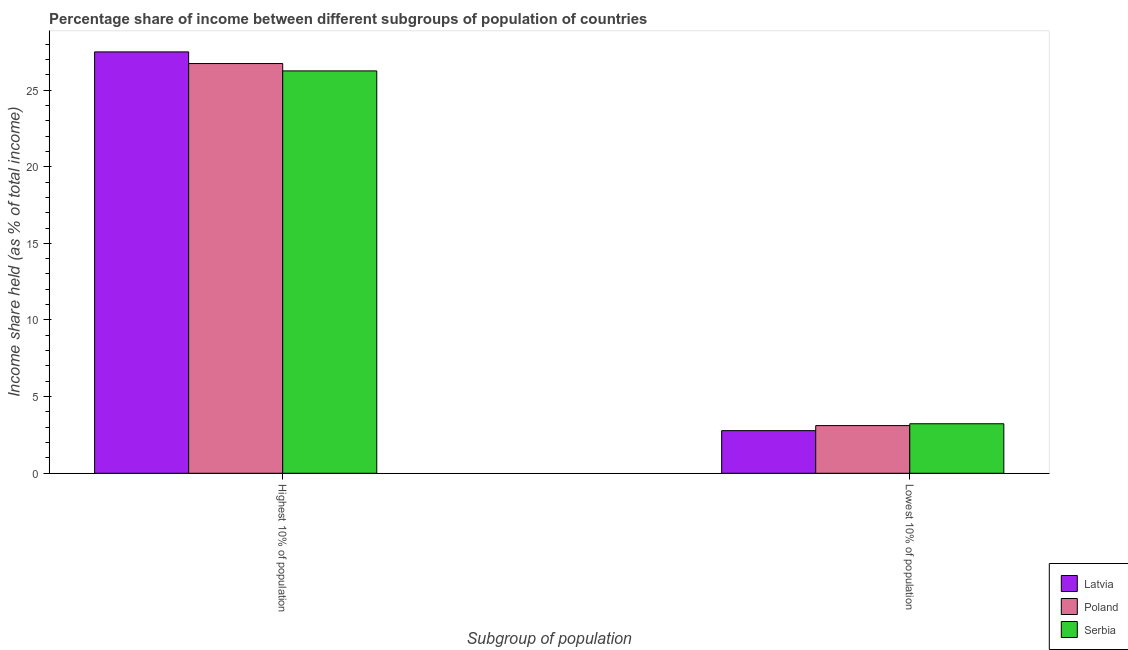How many different coloured bars are there?
Offer a very short reply. 3. How many groups of bars are there?
Ensure brevity in your answer.  2. Are the number of bars on each tick of the X-axis equal?
Make the answer very short. Yes. How many bars are there on the 1st tick from the left?
Give a very brief answer. 3. How many bars are there on the 1st tick from the right?
Your answer should be very brief. 3. What is the label of the 1st group of bars from the left?
Offer a very short reply. Highest 10% of population. What is the income share held by highest 10% of the population in Serbia?
Give a very brief answer. 26.25. Across all countries, what is the maximum income share held by lowest 10% of the population?
Offer a very short reply. 3.23. Across all countries, what is the minimum income share held by highest 10% of the population?
Give a very brief answer. 26.25. In which country was the income share held by lowest 10% of the population maximum?
Your response must be concise. Serbia. In which country was the income share held by highest 10% of the population minimum?
Give a very brief answer. Serbia. What is the total income share held by highest 10% of the population in the graph?
Give a very brief answer. 80.47. What is the difference between the income share held by highest 10% of the population in Poland and that in Serbia?
Offer a very short reply. 0.48. What is the difference between the income share held by lowest 10% of the population in Serbia and the income share held by highest 10% of the population in Poland?
Keep it short and to the point. -23.5. What is the average income share held by highest 10% of the population per country?
Keep it short and to the point. 26.82. What is the difference between the income share held by lowest 10% of the population and income share held by highest 10% of the population in Poland?
Your answer should be compact. -23.62. In how many countries, is the income share held by lowest 10% of the population greater than 2 %?
Offer a terse response. 3. What is the ratio of the income share held by lowest 10% of the population in Poland to that in Latvia?
Your response must be concise. 1.12. In how many countries, is the income share held by lowest 10% of the population greater than the average income share held by lowest 10% of the population taken over all countries?
Your answer should be compact. 2. What does the 1st bar from the left in Highest 10% of population represents?
Provide a succinct answer. Latvia. What does the 1st bar from the right in Lowest 10% of population represents?
Ensure brevity in your answer.  Serbia. How many bars are there?
Provide a succinct answer. 6. Are all the bars in the graph horizontal?
Keep it short and to the point. No. How many countries are there in the graph?
Give a very brief answer. 3. What is the difference between two consecutive major ticks on the Y-axis?
Give a very brief answer. 5. Are the values on the major ticks of Y-axis written in scientific E-notation?
Provide a succinct answer. No. Does the graph contain any zero values?
Give a very brief answer. No. Does the graph contain grids?
Your answer should be compact. No. Where does the legend appear in the graph?
Offer a terse response. Bottom right. What is the title of the graph?
Your response must be concise. Percentage share of income between different subgroups of population of countries. Does "Lao PDR" appear as one of the legend labels in the graph?
Keep it short and to the point. No. What is the label or title of the X-axis?
Keep it short and to the point. Subgroup of population. What is the label or title of the Y-axis?
Keep it short and to the point. Income share held (as % of total income). What is the Income share held (as % of total income) of Latvia in Highest 10% of population?
Your answer should be compact. 27.49. What is the Income share held (as % of total income) of Poland in Highest 10% of population?
Your answer should be very brief. 26.73. What is the Income share held (as % of total income) of Serbia in Highest 10% of population?
Make the answer very short. 26.25. What is the Income share held (as % of total income) of Latvia in Lowest 10% of population?
Provide a succinct answer. 2.78. What is the Income share held (as % of total income) of Poland in Lowest 10% of population?
Keep it short and to the point. 3.11. What is the Income share held (as % of total income) of Serbia in Lowest 10% of population?
Give a very brief answer. 3.23. Across all Subgroup of population, what is the maximum Income share held (as % of total income) of Latvia?
Give a very brief answer. 27.49. Across all Subgroup of population, what is the maximum Income share held (as % of total income) in Poland?
Make the answer very short. 26.73. Across all Subgroup of population, what is the maximum Income share held (as % of total income) of Serbia?
Your answer should be very brief. 26.25. Across all Subgroup of population, what is the minimum Income share held (as % of total income) of Latvia?
Offer a terse response. 2.78. Across all Subgroup of population, what is the minimum Income share held (as % of total income) of Poland?
Your answer should be very brief. 3.11. Across all Subgroup of population, what is the minimum Income share held (as % of total income) in Serbia?
Make the answer very short. 3.23. What is the total Income share held (as % of total income) of Latvia in the graph?
Give a very brief answer. 30.27. What is the total Income share held (as % of total income) of Poland in the graph?
Ensure brevity in your answer.  29.84. What is the total Income share held (as % of total income) in Serbia in the graph?
Provide a succinct answer. 29.48. What is the difference between the Income share held (as % of total income) in Latvia in Highest 10% of population and that in Lowest 10% of population?
Your response must be concise. 24.71. What is the difference between the Income share held (as % of total income) of Poland in Highest 10% of population and that in Lowest 10% of population?
Offer a very short reply. 23.62. What is the difference between the Income share held (as % of total income) of Serbia in Highest 10% of population and that in Lowest 10% of population?
Give a very brief answer. 23.02. What is the difference between the Income share held (as % of total income) of Latvia in Highest 10% of population and the Income share held (as % of total income) of Poland in Lowest 10% of population?
Offer a very short reply. 24.38. What is the difference between the Income share held (as % of total income) in Latvia in Highest 10% of population and the Income share held (as % of total income) in Serbia in Lowest 10% of population?
Your response must be concise. 24.26. What is the difference between the Income share held (as % of total income) in Poland in Highest 10% of population and the Income share held (as % of total income) in Serbia in Lowest 10% of population?
Your answer should be compact. 23.5. What is the average Income share held (as % of total income) of Latvia per Subgroup of population?
Your answer should be compact. 15.13. What is the average Income share held (as % of total income) in Poland per Subgroup of population?
Ensure brevity in your answer.  14.92. What is the average Income share held (as % of total income) in Serbia per Subgroup of population?
Provide a short and direct response. 14.74. What is the difference between the Income share held (as % of total income) in Latvia and Income share held (as % of total income) in Poland in Highest 10% of population?
Keep it short and to the point. 0.76. What is the difference between the Income share held (as % of total income) of Latvia and Income share held (as % of total income) of Serbia in Highest 10% of population?
Give a very brief answer. 1.24. What is the difference between the Income share held (as % of total income) of Poland and Income share held (as % of total income) of Serbia in Highest 10% of population?
Offer a very short reply. 0.48. What is the difference between the Income share held (as % of total income) in Latvia and Income share held (as % of total income) in Poland in Lowest 10% of population?
Your response must be concise. -0.33. What is the difference between the Income share held (as % of total income) of Latvia and Income share held (as % of total income) of Serbia in Lowest 10% of population?
Give a very brief answer. -0.45. What is the difference between the Income share held (as % of total income) of Poland and Income share held (as % of total income) of Serbia in Lowest 10% of population?
Offer a very short reply. -0.12. What is the ratio of the Income share held (as % of total income) in Latvia in Highest 10% of population to that in Lowest 10% of population?
Keep it short and to the point. 9.89. What is the ratio of the Income share held (as % of total income) of Poland in Highest 10% of population to that in Lowest 10% of population?
Keep it short and to the point. 8.59. What is the ratio of the Income share held (as % of total income) in Serbia in Highest 10% of population to that in Lowest 10% of population?
Keep it short and to the point. 8.13. What is the difference between the highest and the second highest Income share held (as % of total income) in Latvia?
Provide a short and direct response. 24.71. What is the difference between the highest and the second highest Income share held (as % of total income) of Poland?
Make the answer very short. 23.62. What is the difference between the highest and the second highest Income share held (as % of total income) in Serbia?
Give a very brief answer. 23.02. What is the difference between the highest and the lowest Income share held (as % of total income) of Latvia?
Ensure brevity in your answer.  24.71. What is the difference between the highest and the lowest Income share held (as % of total income) in Poland?
Ensure brevity in your answer.  23.62. What is the difference between the highest and the lowest Income share held (as % of total income) in Serbia?
Provide a short and direct response. 23.02. 